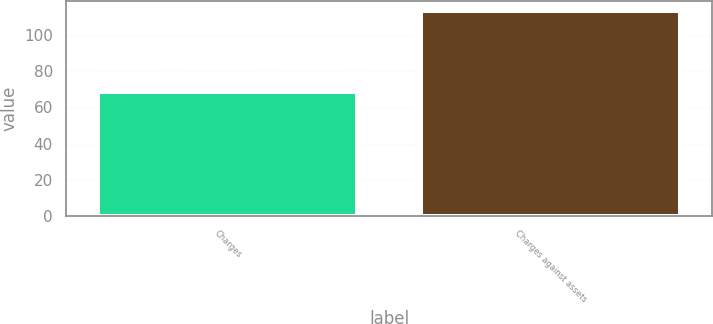Convert chart to OTSL. <chart><loc_0><loc_0><loc_500><loc_500><bar_chart><fcel>Charges<fcel>Charges against assets<nl><fcel>68.7<fcel>113.3<nl></chart> 